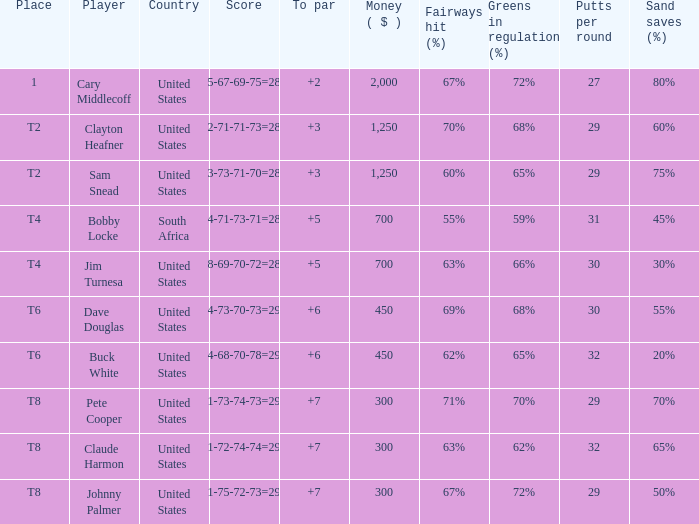What is the Johnny Palmer with a To larger than 6 Money sum? 300.0. 